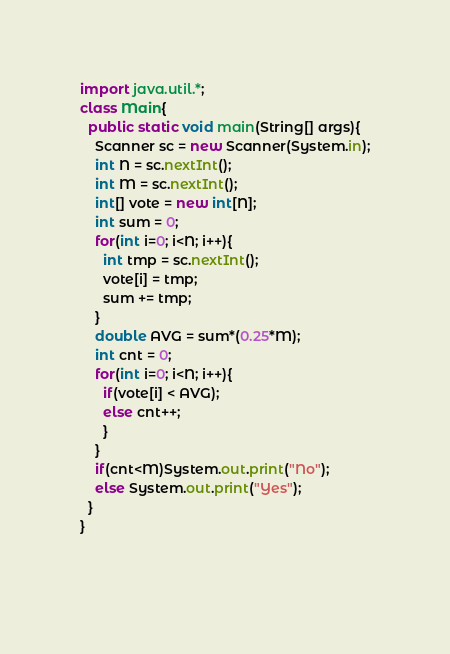<code> <loc_0><loc_0><loc_500><loc_500><_Java_>import java.util.*;
class Main{
  public static void main(String[] args){
    Scanner sc = new Scanner(System.in);
    int N = sc.nextInt();
    int M = sc.nextInt();
    int[] vote = new int[N];
    int sum = 0;
    for(int i=0; i<N; i++){
      int tmp = sc.nextInt();
      vote[i] = tmp;
      sum += tmp;
    }
    double AVG = sum*(0.25*M);
    int cnt = 0;
    for(int i=0; i<N; i++){
      if(vote[i] < AVG);
      else cnt++;
      }
    }
    if(cnt<M)System.out.print("No");
  	else System.out.print("Yes");
  }
}
    
    
</code> 